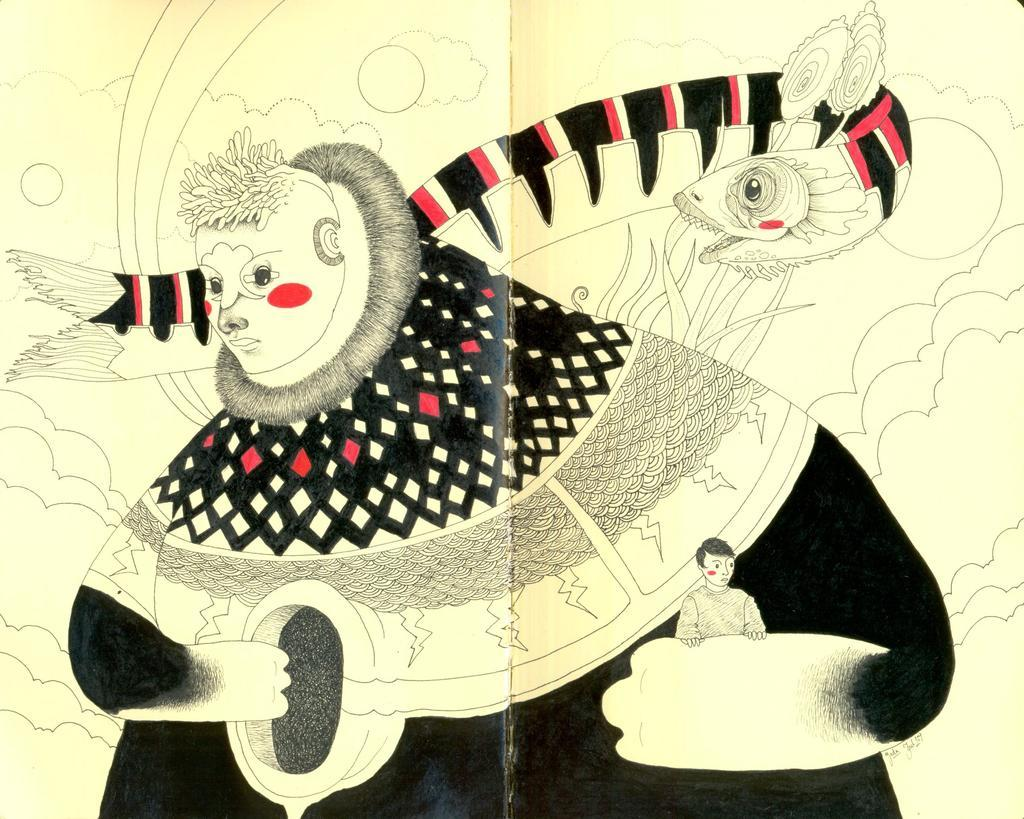What medium is used for the image? The image appears to be a drawing on paper. What is the main subject of the drawing? There is a person depicted in the drawing. Are there any other subjects in the drawing besides the person? Yes, there is a fish depicted in the drawing. What type of thumb is being used to draw the image? There is no thumb present in the image, as it is a drawing on paper and not an actual person drawing. 